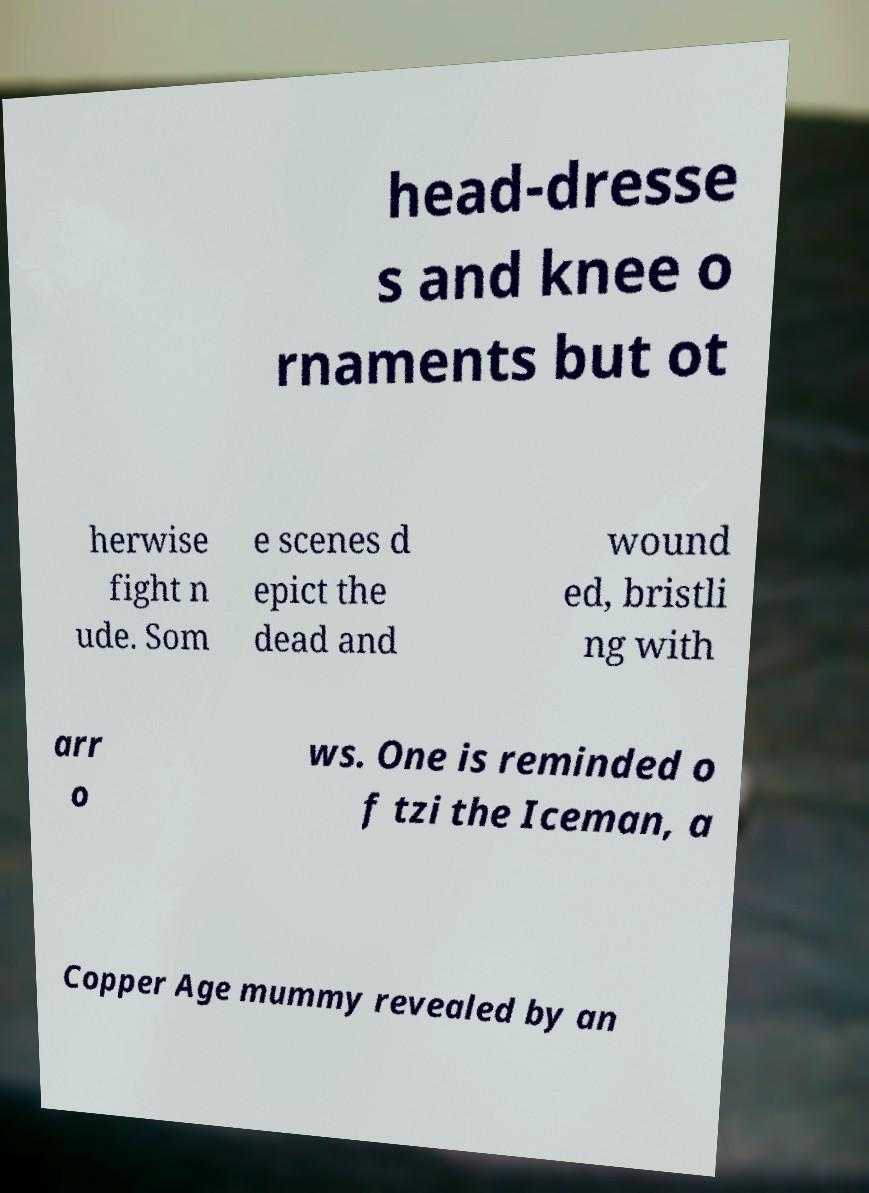For documentation purposes, I need the text within this image transcribed. Could you provide that? head-dresse s and knee o rnaments but ot herwise fight n ude. Som e scenes d epict the dead and wound ed, bristli ng with arr o ws. One is reminded o f tzi the Iceman, a Copper Age mummy revealed by an 